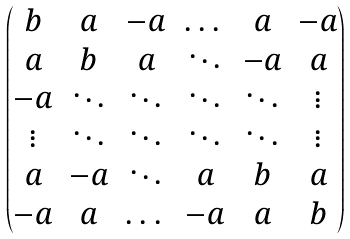Convert formula to latex. <formula><loc_0><loc_0><loc_500><loc_500>\begin{pmatrix} b & a & - a & \dots & a & - a \\ a & b & a & \ddots & - a & a \\ - a & \ddots & \ddots & \ddots & \ddots & \vdots \\ \vdots & \ddots & \ddots & \ddots & \ddots & \vdots \\ a & - a & \ddots & a & b & a \\ - a & a & \dots & - a & a & b \end{pmatrix}</formula> 